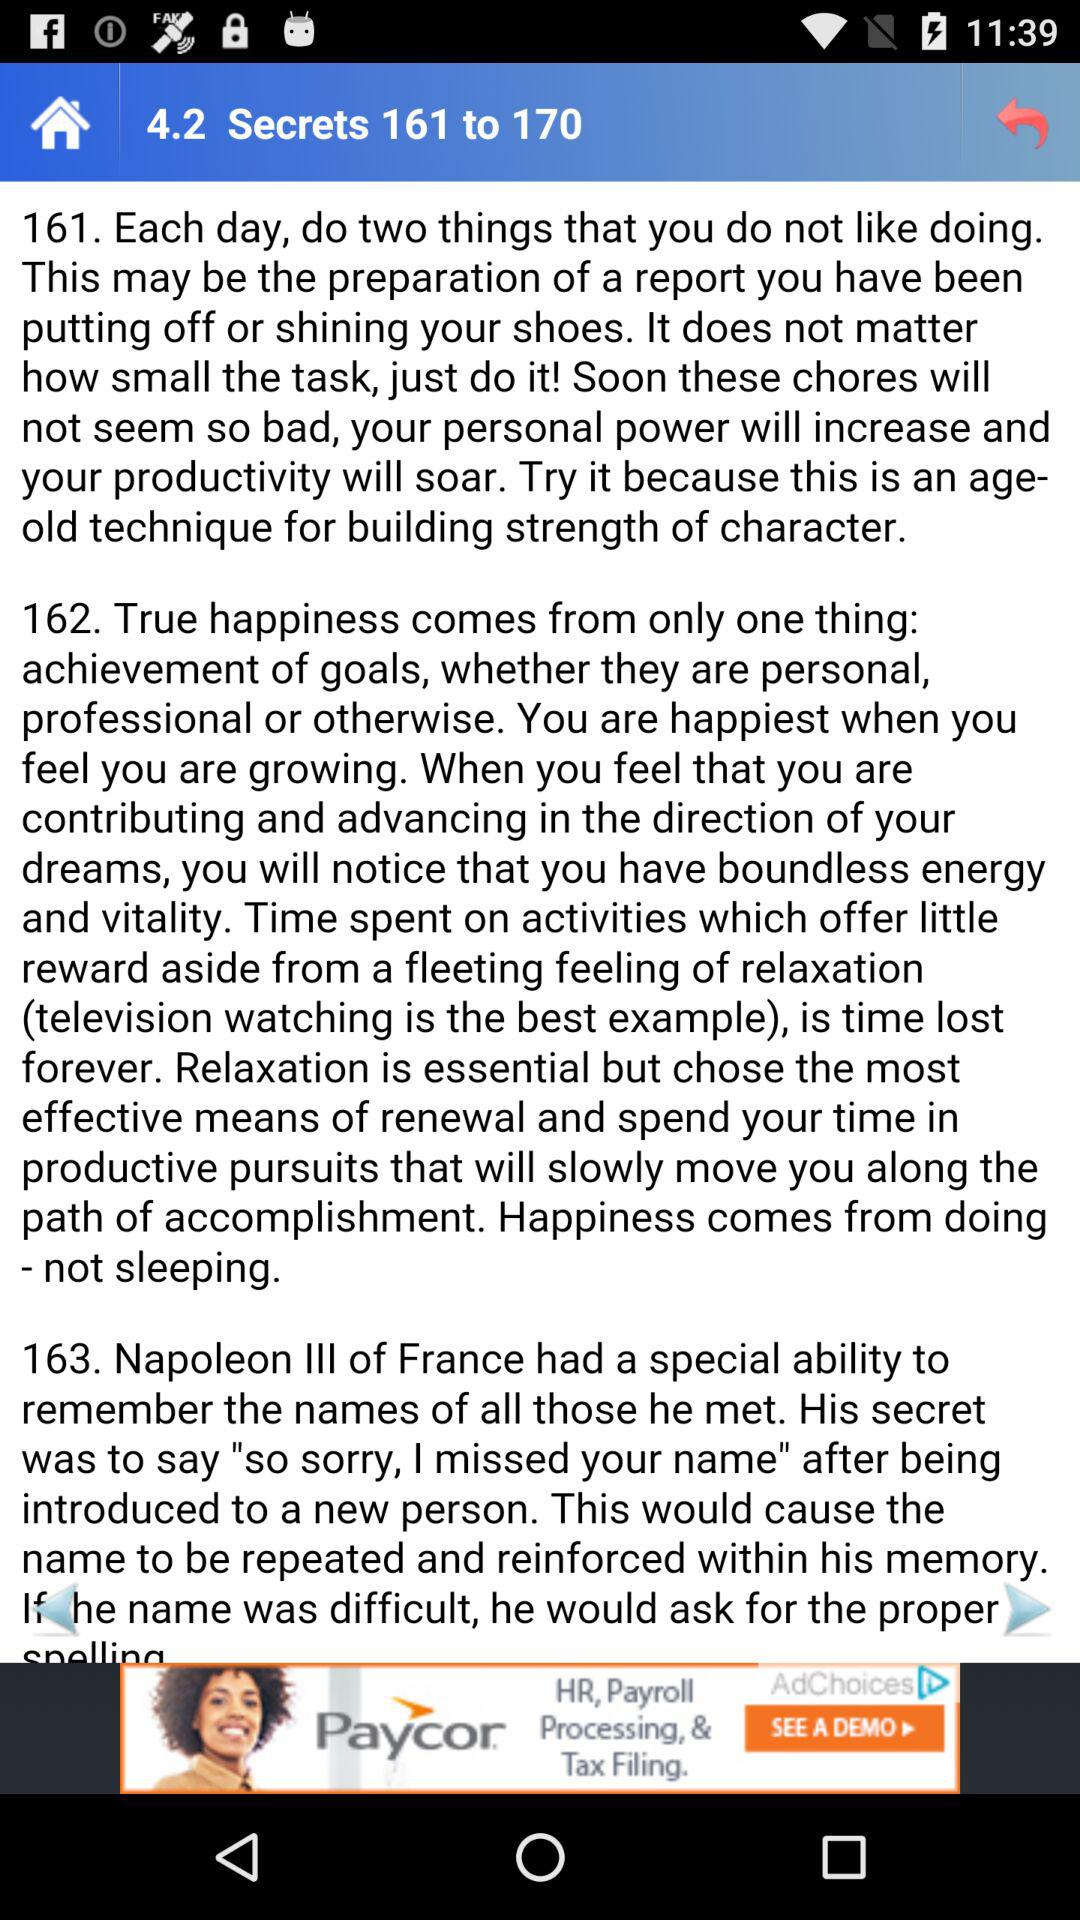How many sections of text are there on this screen?
Answer the question using a single word or phrase. 3 